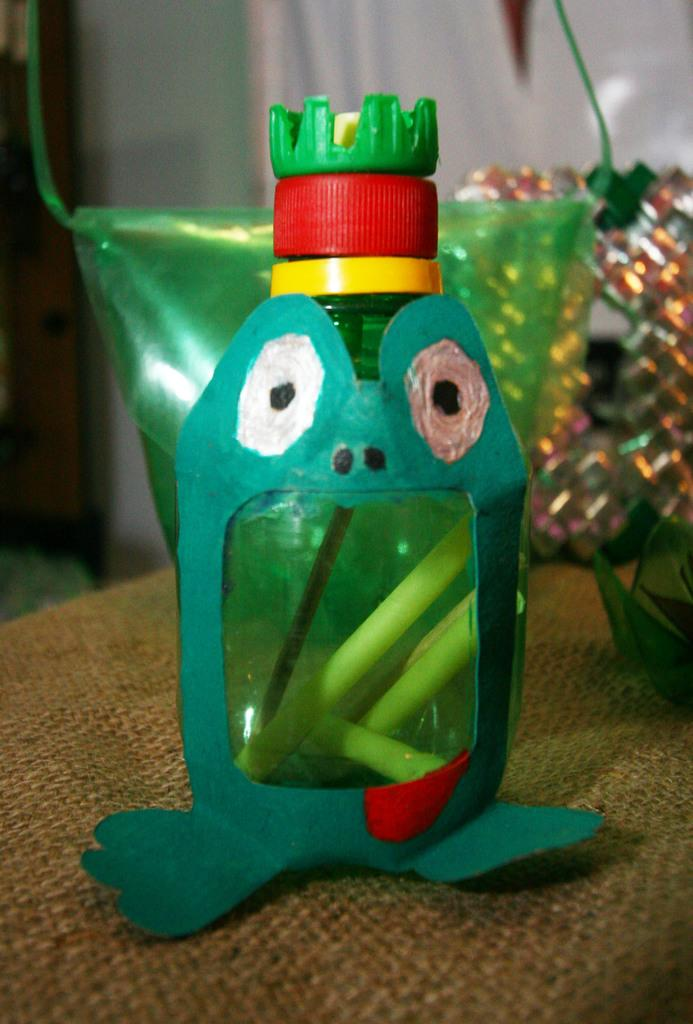What is the main object on the table in the image? There is a colored bottle on the table. Are there any other objects on the table besides the colored bottle? Yes, there are other objects on the table. What language is the fly speaking in the image? There is no fly present in the image, so it is not possible to determine what language it might be speaking. 